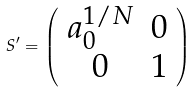<formula> <loc_0><loc_0><loc_500><loc_500>S ^ { \prime } = \left ( \begin{array} { c c } a _ { 0 } ^ { 1 / N } & 0 \\ 0 & 1 \end{array} \right )</formula> 